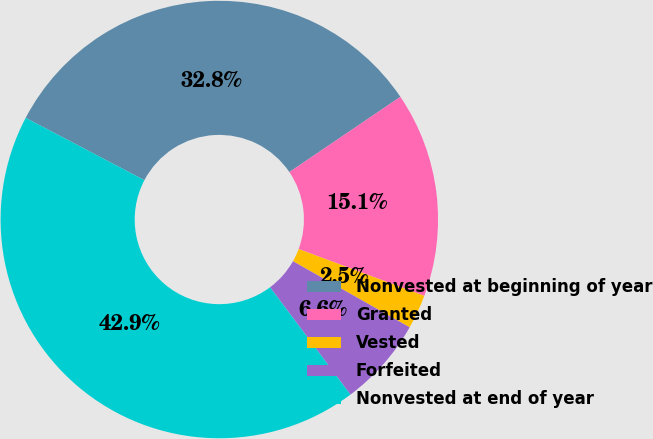Convert chart. <chart><loc_0><loc_0><loc_500><loc_500><pie_chart><fcel>Nonvested at beginning of year<fcel>Granted<fcel>Vested<fcel>Forfeited<fcel>Nonvested at end of year<nl><fcel>32.83%<fcel>15.15%<fcel>2.53%<fcel>6.57%<fcel>42.93%<nl></chart> 